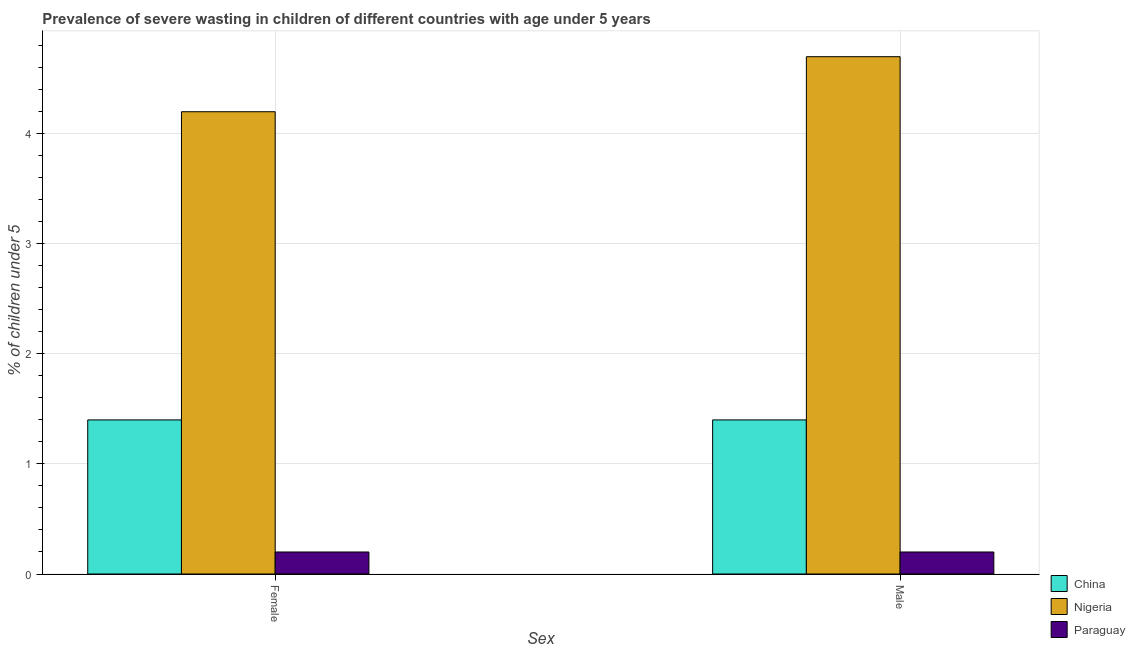How many bars are there on the 1st tick from the left?
Give a very brief answer. 3. What is the percentage of undernourished male children in Nigeria?
Your answer should be very brief. 4.7. Across all countries, what is the maximum percentage of undernourished female children?
Your answer should be very brief. 4.2. Across all countries, what is the minimum percentage of undernourished male children?
Offer a very short reply. 0.2. In which country was the percentage of undernourished male children maximum?
Give a very brief answer. Nigeria. In which country was the percentage of undernourished male children minimum?
Give a very brief answer. Paraguay. What is the total percentage of undernourished female children in the graph?
Keep it short and to the point. 5.8. What is the difference between the percentage of undernourished male children in China and that in Nigeria?
Provide a succinct answer. -3.3. What is the difference between the percentage of undernourished female children in China and the percentage of undernourished male children in Nigeria?
Keep it short and to the point. -3.3. What is the average percentage of undernourished female children per country?
Provide a short and direct response. 1.93. What is the difference between the percentage of undernourished male children and percentage of undernourished female children in China?
Make the answer very short. 0. In how many countries, is the percentage of undernourished male children greater than 3.4 %?
Provide a succinct answer. 1. What is the ratio of the percentage of undernourished male children in Nigeria to that in Paraguay?
Make the answer very short. 23.5. Is the percentage of undernourished female children in Nigeria less than that in China?
Give a very brief answer. No. In how many countries, is the percentage of undernourished female children greater than the average percentage of undernourished female children taken over all countries?
Your answer should be very brief. 1. What does the 1st bar from the left in Male represents?
Provide a short and direct response. China. What does the 2nd bar from the right in Female represents?
Provide a short and direct response. Nigeria. What is the difference between two consecutive major ticks on the Y-axis?
Offer a terse response. 1. Does the graph contain grids?
Offer a terse response. Yes. Where does the legend appear in the graph?
Provide a short and direct response. Bottom right. How many legend labels are there?
Keep it short and to the point. 3. How are the legend labels stacked?
Provide a succinct answer. Vertical. What is the title of the graph?
Offer a terse response. Prevalence of severe wasting in children of different countries with age under 5 years. What is the label or title of the X-axis?
Offer a very short reply. Sex. What is the label or title of the Y-axis?
Your response must be concise.  % of children under 5. What is the  % of children under 5 of China in Female?
Offer a very short reply. 1.4. What is the  % of children under 5 in Nigeria in Female?
Ensure brevity in your answer.  4.2. What is the  % of children under 5 in Paraguay in Female?
Provide a short and direct response. 0.2. What is the  % of children under 5 of China in Male?
Your answer should be compact. 1.4. What is the  % of children under 5 in Nigeria in Male?
Keep it short and to the point. 4.7. What is the  % of children under 5 of Paraguay in Male?
Make the answer very short. 0.2. Across all Sex, what is the maximum  % of children under 5 of China?
Provide a short and direct response. 1.4. Across all Sex, what is the maximum  % of children under 5 of Nigeria?
Ensure brevity in your answer.  4.7. Across all Sex, what is the maximum  % of children under 5 of Paraguay?
Provide a succinct answer. 0.2. Across all Sex, what is the minimum  % of children under 5 of China?
Keep it short and to the point. 1.4. Across all Sex, what is the minimum  % of children under 5 of Nigeria?
Offer a terse response. 4.2. Across all Sex, what is the minimum  % of children under 5 in Paraguay?
Your answer should be very brief. 0.2. What is the total  % of children under 5 of Paraguay in the graph?
Your response must be concise. 0.4. What is the difference between the  % of children under 5 of Paraguay in Female and that in Male?
Your answer should be compact. 0. What is the difference between the  % of children under 5 of China in Female and the  % of children under 5 of Nigeria in Male?
Your response must be concise. -3.3. What is the average  % of children under 5 of Nigeria per Sex?
Your response must be concise. 4.45. What is the difference between the  % of children under 5 in China and  % of children under 5 in Paraguay in Female?
Provide a succinct answer. 1.2. What is the difference between the  % of children under 5 of China and  % of children under 5 of Nigeria in Male?
Your response must be concise. -3.3. What is the difference between the  % of children under 5 in China and  % of children under 5 in Paraguay in Male?
Keep it short and to the point. 1.2. What is the difference between the  % of children under 5 in Nigeria and  % of children under 5 in Paraguay in Male?
Your response must be concise. 4.5. What is the ratio of the  % of children under 5 of China in Female to that in Male?
Provide a short and direct response. 1. What is the ratio of the  % of children under 5 of Nigeria in Female to that in Male?
Provide a succinct answer. 0.89. What is the difference between the highest and the second highest  % of children under 5 of China?
Keep it short and to the point. 0. What is the difference between the highest and the second highest  % of children under 5 of Nigeria?
Provide a short and direct response. 0.5. What is the difference between the highest and the second highest  % of children under 5 in Paraguay?
Keep it short and to the point. 0. What is the difference between the highest and the lowest  % of children under 5 of Nigeria?
Your response must be concise. 0.5. 